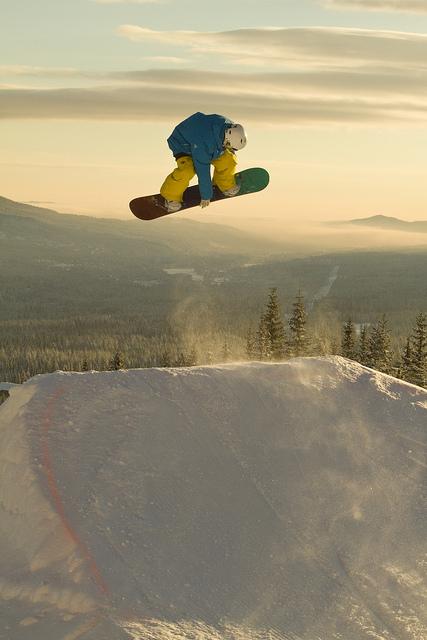What is this man holding?
Give a very brief answer. Snowboard. Is the snowboarder in midair?
Quick response, please. Yes. Is there grass on the ground?
Answer briefly. No. Is there a mountain in the background?
Concise answer only. Yes. 